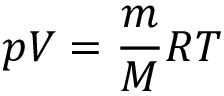<formula> <loc_0><loc_0><loc_500><loc_500>p V = { \frac { m } { M } } R T</formula> 